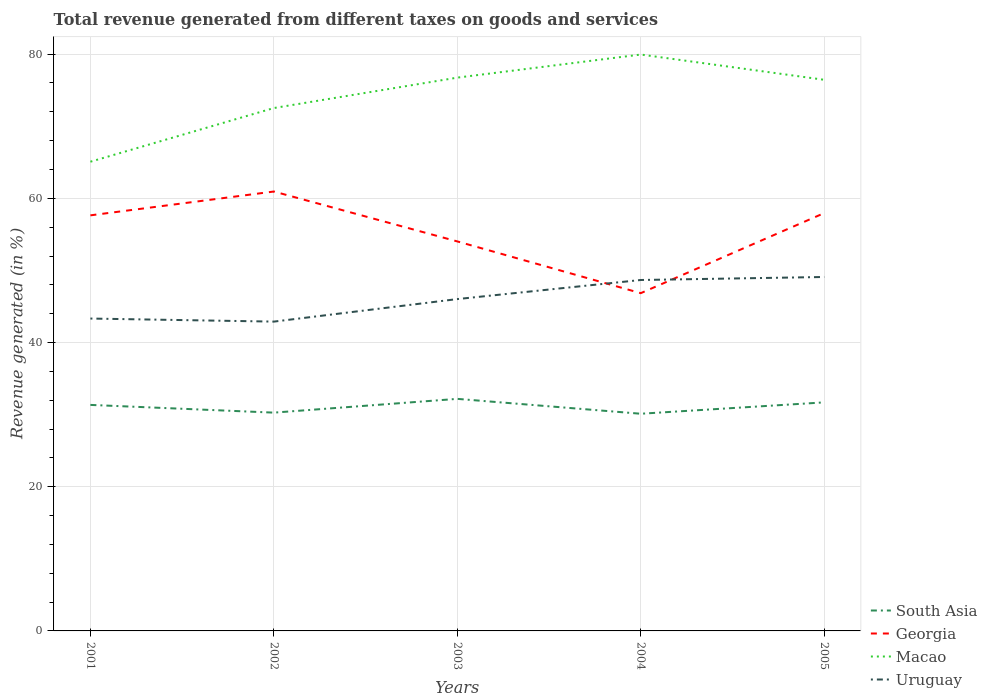How many different coloured lines are there?
Provide a succinct answer. 4. Does the line corresponding to Georgia intersect with the line corresponding to Macao?
Offer a terse response. No. Across all years, what is the maximum total revenue generated in Macao?
Offer a terse response. 65.08. In which year was the total revenue generated in Georgia maximum?
Make the answer very short. 2004. What is the total total revenue generated in South Asia in the graph?
Ensure brevity in your answer.  1.23. What is the difference between the highest and the second highest total revenue generated in Georgia?
Your response must be concise. 14.1. Does the graph contain grids?
Offer a terse response. Yes. How are the legend labels stacked?
Offer a terse response. Vertical. What is the title of the graph?
Your answer should be compact. Total revenue generated from different taxes on goods and services. What is the label or title of the Y-axis?
Offer a very short reply. Revenue generated (in %). What is the Revenue generated (in %) in South Asia in 2001?
Ensure brevity in your answer.  31.35. What is the Revenue generated (in %) of Georgia in 2001?
Provide a short and direct response. 57.64. What is the Revenue generated (in %) of Macao in 2001?
Make the answer very short. 65.08. What is the Revenue generated (in %) of Uruguay in 2001?
Your answer should be very brief. 43.33. What is the Revenue generated (in %) in South Asia in 2002?
Ensure brevity in your answer.  30.28. What is the Revenue generated (in %) of Georgia in 2002?
Provide a succinct answer. 60.94. What is the Revenue generated (in %) in Macao in 2002?
Your answer should be compact. 72.52. What is the Revenue generated (in %) of Uruguay in 2002?
Give a very brief answer. 42.9. What is the Revenue generated (in %) in South Asia in 2003?
Your response must be concise. 32.19. What is the Revenue generated (in %) in Georgia in 2003?
Make the answer very short. 54.02. What is the Revenue generated (in %) in Macao in 2003?
Offer a very short reply. 76.74. What is the Revenue generated (in %) of Uruguay in 2003?
Make the answer very short. 46.03. What is the Revenue generated (in %) of South Asia in 2004?
Offer a terse response. 30.12. What is the Revenue generated (in %) in Georgia in 2004?
Keep it short and to the point. 46.85. What is the Revenue generated (in %) of Macao in 2004?
Provide a short and direct response. 79.94. What is the Revenue generated (in %) in Uruguay in 2004?
Make the answer very short. 48.67. What is the Revenue generated (in %) in South Asia in 2005?
Keep it short and to the point. 31.7. What is the Revenue generated (in %) of Georgia in 2005?
Ensure brevity in your answer.  57.95. What is the Revenue generated (in %) in Macao in 2005?
Ensure brevity in your answer.  76.44. What is the Revenue generated (in %) in Uruguay in 2005?
Make the answer very short. 49.09. Across all years, what is the maximum Revenue generated (in %) in South Asia?
Provide a short and direct response. 32.19. Across all years, what is the maximum Revenue generated (in %) of Georgia?
Offer a very short reply. 60.94. Across all years, what is the maximum Revenue generated (in %) in Macao?
Offer a very short reply. 79.94. Across all years, what is the maximum Revenue generated (in %) of Uruguay?
Ensure brevity in your answer.  49.09. Across all years, what is the minimum Revenue generated (in %) in South Asia?
Keep it short and to the point. 30.12. Across all years, what is the minimum Revenue generated (in %) in Georgia?
Keep it short and to the point. 46.85. Across all years, what is the minimum Revenue generated (in %) of Macao?
Give a very brief answer. 65.08. Across all years, what is the minimum Revenue generated (in %) of Uruguay?
Your answer should be very brief. 42.9. What is the total Revenue generated (in %) of South Asia in the graph?
Make the answer very short. 155.63. What is the total Revenue generated (in %) of Georgia in the graph?
Your response must be concise. 277.41. What is the total Revenue generated (in %) of Macao in the graph?
Keep it short and to the point. 370.73. What is the total Revenue generated (in %) in Uruguay in the graph?
Your response must be concise. 230.01. What is the difference between the Revenue generated (in %) of South Asia in 2001 and that in 2002?
Offer a very short reply. 1.07. What is the difference between the Revenue generated (in %) of Georgia in 2001 and that in 2002?
Keep it short and to the point. -3.31. What is the difference between the Revenue generated (in %) of Macao in 2001 and that in 2002?
Your answer should be very brief. -7.45. What is the difference between the Revenue generated (in %) in Uruguay in 2001 and that in 2002?
Keep it short and to the point. 0.43. What is the difference between the Revenue generated (in %) of South Asia in 2001 and that in 2003?
Provide a short and direct response. -0.84. What is the difference between the Revenue generated (in %) of Georgia in 2001 and that in 2003?
Give a very brief answer. 3.62. What is the difference between the Revenue generated (in %) in Macao in 2001 and that in 2003?
Give a very brief answer. -11.66. What is the difference between the Revenue generated (in %) of Uruguay in 2001 and that in 2003?
Make the answer very short. -2.7. What is the difference between the Revenue generated (in %) of South Asia in 2001 and that in 2004?
Ensure brevity in your answer.  1.23. What is the difference between the Revenue generated (in %) of Georgia in 2001 and that in 2004?
Offer a very short reply. 10.79. What is the difference between the Revenue generated (in %) in Macao in 2001 and that in 2004?
Offer a terse response. -14.87. What is the difference between the Revenue generated (in %) in Uruguay in 2001 and that in 2004?
Make the answer very short. -5.35. What is the difference between the Revenue generated (in %) in South Asia in 2001 and that in 2005?
Offer a terse response. -0.35. What is the difference between the Revenue generated (in %) in Georgia in 2001 and that in 2005?
Provide a short and direct response. -0.31. What is the difference between the Revenue generated (in %) in Macao in 2001 and that in 2005?
Your answer should be compact. -11.36. What is the difference between the Revenue generated (in %) in Uruguay in 2001 and that in 2005?
Your answer should be compact. -5.76. What is the difference between the Revenue generated (in %) in South Asia in 2002 and that in 2003?
Provide a short and direct response. -1.91. What is the difference between the Revenue generated (in %) in Georgia in 2002 and that in 2003?
Provide a short and direct response. 6.92. What is the difference between the Revenue generated (in %) of Macao in 2002 and that in 2003?
Offer a terse response. -4.22. What is the difference between the Revenue generated (in %) in Uruguay in 2002 and that in 2003?
Provide a short and direct response. -3.13. What is the difference between the Revenue generated (in %) of South Asia in 2002 and that in 2004?
Provide a short and direct response. 0.15. What is the difference between the Revenue generated (in %) of Georgia in 2002 and that in 2004?
Your response must be concise. 14.1. What is the difference between the Revenue generated (in %) of Macao in 2002 and that in 2004?
Make the answer very short. -7.42. What is the difference between the Revenue generated (in %) in Uruguay in 2002 and that in 2004?
Ensure brevity in your answer.  -5.77. What is the difference between the Revenue generated (in %) of South Asia in 2002 and that in 2005?
Your response must be concise. -1.42. What is the difference between the Revenue generated (in %) in Georgia in 2002 and that in 2005?
Provide a short and direct response. 2.99. What is the difference between the Revenue generated (in %) of Macao in 2002 and that in 2005?
Keep it short and to the point. -3.92. What is the difference between the Revenue generated (in %) in Uruguay in 2002 and that in 2005?
Provide a succinct answer. -6.19. What is the difference between the Revenue generated (in %) of South Asia in 2003 and that in 2004?
Offer a very short reply. 2.06. What is the difference between the Revenue generated (in %) in Georgia in 2003 and that in 2004?
Your response must be concise. 7.18. What is the difference between the Revenue generated (in %) of Macao in 2003 and that in 2004?
Your answer should be very brief. -3.2. What is the difference between the Revenue generated (in %) of Uruguay in 2003 and that in 2004?
Provide a succinct answer. -2.65. What is the difference between the Revenue generated (in %) in South Asia in 2003 and that in 2005?
Give a very brief answer. 0.49. What is the difference between the Revenue generated (in %) in Georgia in 2003 and that in 2005?
Keep it short and to the point. -3.93. What is the difference between the Revenue generated (in %) of Macao in 2003 and that in 2005?
Provide a succinct answer. 0.3. What is the difference between the Revenue generated (in %) in Uruguay in 2003 and that in 2005?
Offer a terse response. -3.06. What is the difference between the Revenue generated (in %) in South Asia in 2004 and that in 2005?
Make the answer very short. -1.58. What is the difference between the Revenue generated (in %) in Georgia in 2004 and that in 2005?
Ensure brevity in your answer.  -11.11. What is the difference between the Revenue generated (in %) of Macao in 2004 and that in 2005?
Provide a succinct answer. 3.5. What is the difference between the Revenue generated (in %) in Uruguay in 2004 and that in 2005?
Give a very brief answer. -0.42. What is the difference between the Revenue generated (in %) of South Asia in 2001 and the Revenue generated (in %) of Georgia in 2002?
Give a very brief answer. -29.6. What is the difference between the Revenue generated (in %) in South Asia in 2001 and the Revenue generated (in %) in Macao in 2002?
Provide a short and direct response. -41.17. What is the difference between the Revenue generated (in %) of South Asia in 2001 and the Revenue generated (in %) of Uruguay in 2002?
Offer a very short reply. -11.55. What is the difference between the Revenue generated (in %) of Georgia in 2001 and the Revenue generated (in %) of Macao in 2002?
Provide a short and direct response. -14.88. What is the difference between the Revenue generated (in %) of Georgia in 2001 and the Revenue generated (in %) of Uruguay in 2002?
Provide a succinct answer. 14.74. What is the difference between the Revenue generated (in %) of Macao in 2001 and the Revenue generated (in %) of Uruguay in 2002?
Give a very brief answer. 22.18. What is the difference between the Revenue generated (in %) in South Asia in 2001 and the Revenue generated (in %) in Georgia in 2003?
Make the answer very short. -22.67. What is the difference between the Revenue generated (in %) in South Asia in 2001 and the Revenue generated (in %) in Macao in 2003?
Offer a terse response. -45.39. What is the difference between the Revenue generated (in %) of South Asia in 2001 and the Revenue generated (in %) of Uruguay in 2003?
Keep it short and to the point. -14.68. What is the difference between the Revenue generated (in %) in Georgia in 2001 and the Revenue generated (in %) in Macao in 2003?
Provide a succinct answer. -19.1. What is the difference between the Revenue generated (in %) in Georgia in 2001 and the Revenue generated (in %) in Uruguay in 2003?
Offer a very short reply. 11.61. What is the difference between the Revenue generated (in %) in Macao in 2001 and the Revenue generated (in %) in Uruguay in 2003?
Offer a terse response. 19.05. What is the difference between the Revenue generated (in %) of South Asia in 2001 and the Revenue generated (in %) of Georgia in 2004?
Offer a very short reply. -15.5. What is the difference between the Revenue generated (in %) of South Asia in 2001 and the Revenue generated (in %) of Macao in 2004?
Ensure brevity in your answer.  -48.59. What is the difference between the Revenue generated (in %) in South Asia in 2001 and the Revenue generated (in %) in Uruguay in 2004?
Ensure brevity in your answer.  -17.32. What is the difference between the Revenue generated (in %) in Georgia in 2001 and the Revenue generated (in %) in Macao in 2004?
Ensure brevity in your answer.  -22.3. What is the difference between the Revenue generated (in %) in Georgia in 2001 and the Revenue generated (in %) in Uruguay in 2004?
Ensure brevity in your answer.  8.97. What is the difference between the Revenue generated (in %) of Macao in 2001 and the Revenue generated (in %) of Uruguay in 2004?
Your answer should be compact. 16.41. What is the difference between the Revenue generated (in %) in South Asia in 2001 and the Revenue generated (in %) in Georgia in 2005?
Give a very brief answer. -26.6. What is the difference between the Revenue generated (in %) of South Asia in 2001 and the Revenue generated (in %) of Macao in 2005?
Your answer should be compact. -45.09. What is the difference between the Revenue generated (in %) of South Asia in 2001 and the Revenue generated (in %) of Uruguay in 2005?
Provide a succinct answer. -17.74. What is the difference between the Revenue generated (in %) in Georgia in 2001 and the Revenue generated (in %) in Macao in 2005?
Offer a very short reply. -18.8. What is the difference between the Revenue generated (in %) in Georgia in 2001 and the Revenue generated (in %) in Uruguay in 2005?
Provide a succinct answer. 8.55. What is the difference between the Revenue generated (in %) of Macao in 2001 and the Revenue generated (in %) of Uruguay in 2005?
Your answer should be compact. 15.99. What is the difference between the Revenue generated (in %) of South Asia in 2002 and the Revenue generated (in %) of Georgia in 2003?
Offer a terse response. -23.75. What is the difference between the Revenue generated (in %) in South Asia in 2002 and the Revenue generated (in %) in Macao in 2003?
Provide a short and direct response. -46.46. What is the difference between the Revenue generated (in %) of South Asia in 2002 and the Revenue generated (in %) of Uruguay in 2003?
Provide a short and direct response. -15.75. What is the difference between the Revenue generated (in %) of Georgia in 2002 and the Revenue generated (in %) of Macao in 2003?
Provide a short and direct response. -15.8. What is the difference between the Revenue generated (in %) in Georgia in 2002 and the Revenue generated (in %) in Uruguay in 2003?
Keep it short and to the point. 14.92. What is the difference between the Revenue generated (in %) in Macao in 2002 and the Revenue generated (in %) in Uruguay in 2003?
Your response must be concise. 26.5. What is the difference between the Revenue generated (in %) of South Asia in 2002 and the Revenue generated (in %) of Georgia in 2004?
Ensure brevity in your answer.  -16.57. What is the difference between the Revenue generated (in %) in South Asia in 2002 and the Revenue generated (in %) in Macao in 2004?
Provide a succinct answer. -49.67. What is the difference between the Revenue generated (in %) of South Asia in 2002 and the Revenue generated (in %) of Uruguay in 2004?
Give a very brief answer. -18.4. What is the difference between the Revenue generated (in %) in Georgia in 2002 and the Revenue generated (in %) in Macao in 2004?
Offer a very short reply. -19. What is the difference between the Revenue generated (in %) in Georgia in 2002 and the Revenue generated (in %) in Uruguay in 2004?
Provide a succinct answer. 12.27. What is the difference between the Revenue generated (in %) of Macao in 2002 and the Revenue generated (in %) of Uruguay in 2004?
Make the answer very short. 23.85. What is the difference between the Revenue generated (in %) in South Asia in 2002 and the Revenue generated (in %) in Georgia in 2005?
Your response must be concise. -27.68. What is the difference between the Revenue generated (in %) in South Asia in 2002 and the Revenue generated (in %) in Macao in 2005?
Offer a terse response. -46.17. What is the difference between the Revenue generated (in %) in South Asia in 2002 and the Revenue generated (in %) in Uruguay in 2005?
Your answer should be compact. -18.81. What is the difference between the Revenue generated (in %) of Georgia in 2002 and the Revenue generated (in %) of Macao in 2005?
Your response must be concise. -15.5. What is the difference between the Revenue generated (in %) in Georgia in 2002 and the Revenue generated (in %) in Uruguay in 2005?
Your answer should be very brief. 11.85. What is the difference between the Revenue generated (in %) of Macao in 2002 and the Revenue generated (in %) of Uruguay in 2005?
Keep it short and to the point. 23.43. What is the difference between the Revenue generated (in %) in South Asia in 2003 and the Revenue generated (in %) in Georgia in 2004?
Provide a succinct answer. -14.66. What is the difference between the Revenue generated (in %) of South Asia in 2003 and the Revenue generated (in %) of Macao in 2004?
Give a very brief answer. -47.76. What is the difference between the Revenue generated (in %) of South Asia in 2003 and the Revenue generated (in %) of Uruguay in 2004?
Provide a short and direct response. -16.49. What is the difference between the Revenue generated (in %) of Georgia in 2003 and the Revenue generated (in %) of Macao in 2004?
Offer a very short reply. -25.92. What is the difference between the Revenue generated (in %) of Georgia in 2003 and the Revenue generated (in %) of Uruguay in 2004?
Provide a short and direct response. 5.35. What is the difference between the Revenue generated (in %) of Macao in 2003 and the Revenue generated (in %) of Uruguay in 2004?
Your response must be concise. 28.07. What is the difference between the Revenue generated (in %) in South Asia in 2003 and the Revenue generated (in %) in Georgia in 2005?
Offer a very short reply. -25.77. What is the difference between the Revenue generated (in %) of South Asia in 2003 and the Revenue generated (in %) of Macao in 2005?
Offer a terse response. -44.26. What is the difference between the Revenue generated (in %) of South Asia in 2003 and the Revenue generated (in %) of Uruguay in 2005?
Keep it short and to the point. -16.9. What is the difference between the Revenue generated (in %) of Georgia in 2003 and the Revenue generated (in %) of Macao in 2005?
Give a very brief answer. -22.42. What is the difference between the Revenue generated (in %) of Georgia in 2003 and the Revenue generated (in %) of Uruguay in 2005?
Give a very brief answer. 4.93. What is the difference between the Revenue generated (in %) of Macao in 2003 and the Revenue generated (in %) of Uruguay in 2005?
Offer a terse response. 27.65. What is the difference between the Revenue generated (in %) of South Asia in 2004 and the Revenue generated (in %) of Georgia in 2005?
Ensure brevity in your answer.  -27.83. What is the difference between the Revenue generated (in %) in South Asia in 2004 and the Revenue generated (in %) in Macao in 2005?
Keep it short and to the point. -46.32. What is the difference between the Revenue generated (in %) of South Asia in 2004 and the Revenue generated (in %) of Uruguay in 2005?
Your answer should be very brief. -18.97. What is the difference between the Revenue generated (in %) in Georgia in 2004 and the Revenue generated (in %) in Macao in 2005?
Make the answer very short. -29.59. What is the difference between the Revenue generated (in %) in Georgia in 2004 and the Revenue generated (in %) in Uruguay in 2005?
Provide a succinct answer. -2.24. What is the difference between the Revenue generated (in %) in Macao in 2004 and the Revenue generated (in %) in Uruguay in 2005?
Give a very brief answer. 30.85. What is the average Revenue generated (in %) of South Asia per year?
Ensure brevity in your answer.  31.13. What is the average Revenue generated (in %) in Georgia per year?
Keep it short and to the point. 55.48. What is the average Revenue generated (in %) of Macao per year?
Offer a terse response. 74.15. What is the average Revenue generated (in %) of Uruguay per year?
Your answer should be very brief. 46. In the year 2001, what is the difference between the Revenue generated (in %) in South Asia and Revenue generated (in %) in Georgia?
Give a very brief answer. -26.29. In the year 2001, what is the difference between the Revenue generated (in %) in South Asia and Revenue generated (in %) in Macao?
Offer a very short reply. -33.73. In the year 2001, what is the difference between the Revenue generated (in %) of South Asia and Revenue generated (in %) of Uruguay?
Offer a terse response. -11.98. In the year 2001, what is the difference between the Revenue generated (in %) of Georgia and Revenue generated (in %) of Macao?
Your response must be concise. -7.44. In the year 2001, what is the difference between the Revenue generated (in %) of Georgia and Revenue generated (in %) of Uruguay?
Keep it short and to the point. 14.31. In the year 2001, what is the difference between the Revenue generated (in %) of Macao and Revenue generated (in %) of Uruguay?
Keep it short and to the point. 21.75. In the year 2002, what is the difference between the Revenue generated (in %) in South Asia and Revenue generated (in %) in Georgia?
Give a very brief answer. -30.67. In the year 2002, what is the difference between the Revenue generated (in %) in South Asia and Revenue generated (in %) in Macao?
Your response must be concise. -42.25. In the year 2002, what is the difference between the Revenue generated (in %) of South Asia and Revenue generated (in %) of Uruguay?
Your answer should be very brief. -12.62. In the year 2002, what is the difference between the Revenue generated (in %) in Georgia and Revenue generated (in %) in Macao?
Ensure brevity in your answer.  -11.58. In the year 2002, what is the difference between the Revenue generated (in %) in Georgia and Revenue generated (in %) in Uruguay?
Provide a short and direct response. 18.04. In the year 2002, what is the difference between the Revenue generated (in %) of Macao and Revenue generated (in %) of Uruguay?
Make the answer very short. 29.62. In the year 2003, what is the difference between the Revenue generated (in %) of South Asia and Revenue generated (in %) of Georgia?
Your answer should be compact. -21.84. In the year 2003, what is the difference between the Revenue generated (in %) in South Asia and Revenue generated (in %) in Macao?
Your answer should be very brief. -44.55. In the year 2003, what is the difference between the Revenue generated (in %) of South Asia and Revenue generated (in %) of Uruguay?
Provide a succinct answer. -13.84. In the year 2003, what is the difference between the Revenue generated (in %) in Georgia and Revenue generated (in %) in Macao?
Offer a terse response. -22.72. In the year 2003, what is the difference between the Revenue generated (in %) in Georgia and Revenue generated (in %) in Uruguay?
Give a very brief answer. 8. In the year 2003, what is the difference between the Revenue generated (in %) in Macao and Revenue generated (in %) in Uruguay?
Offer a terse response. 30.71. In the year 2004, what is the difference between the Revenue generated (in %) in South Asia and Revenue generated (in %) in Georgia?
Give a very brief answer. -16.72. In the year 2004, what is the difference between the Revenue generated (in %) of South Asia and Revenue generated (in %) of Macao?
Your answer should be compact. -49.82. In the year 2004, what is the difference between the Revenue generated (in %) of South Asia and Revenue generated (in %) of Uruguay?
Make the answer very short. -18.55. In the year 2004, what is the difference between the Revenue generated (in %) in Georgia and Revenue generated (in %) in Macao?
Offer a very short reply. -33.1. In the year 2004, what is the difference between the Revenue generated (in %) in Georgia and Revenue generated (in %) in Uruguay?
Provide a short and direct response. -1.83. In the year 2004, what is the difference between the Revenue generated (in %) in Macao and Revenue generated (in %) in Uruguay?
Give a very brief answer. 31.27. In the year 2005, what is the difference between the Revenue generated (in %) in South Asia and Revenue generated (in %) in Georgia?
Provide a succinct answer. -26.25. In the year 2005, what is the difference between the Revenue generated (in %) in South Asia and Revenue generated (in %) in Macao?
Make the answer very short. -44.74. In the year 2005, what is the difference between the Revenue generated (in %) in South Asia and Revenue generated (in %) in Uruguay?
Give a very brief answer. -17.39. In the year 2005, what is the difference between the Revenue generated (in %) of Georgia and Revenue generated (in %) of Macao?
Make the answer very short. -18.49. In the year 2005, what is the difference between the Revenue generated (in %) of Georgia and Revenue generated (in %) of Uruguay?
Provide a short and direct response. 8.86. In the year 2005, what is the difference between the Revenue generated (in %) of Macao and Revenue generated (in %) of Uruguay?
Your answer should be very brief. 27.35. What is the ratio of the Revenue generated (in %) in South Asia in 2001 to that in 2002?
Your response must be concise. 1.04. What is the ratio of the Revenue generated (in %) in Georgia in 2001 to that in 2002?
Your response must be concise. 0.95. What is the ratio of the Revenue generated (in %) in Macao in 2001 to that in 2002?
Ensure brevity in your answer.  0.9. What is the ratio of the Revenue generated (in %) in Uruguay in 2001 to that in 2002?
Your answer should be compact. 1.01. What is the ratio of the Revenue generated (in %) in South Asia in 2001 to that in 2003?
Provide a succinct answer. 0.97. What is the ratio of the Revenue generated (in %) in Georgia in 2001 to that in 2003?
Offer a terse response. 1.07. What is the ratio of the Revenue generated (in %) in Macao in 2001 to that in 2003?
Keep it short and to the point. 0.85. What is the ratio of the Revenue generated (in %) of Uruguay in 2001 to that in 2003?
Provide a short and direct response. 0.94. What is the ratio of the Revenue generated (in %) in South Asia in 2001 to that in 2004?
Your answer should be compact. 1.04. What is the ratio of the Revenue generated (in %) of Georgia in 2001 to that in 2004?
Your response must be concise. 1.23. What is the ratio of the Revenue generated (in %) of Macao in 2001 to that in 2004?
Provide a succinct answer. 0.81. What is the ratio of the Revenue generated (in %) of Uruguay in 2001 to that in 2004?
Offer a very short reply. 0.89. What is the ratio of the Revenue generated (in %) of South Asia in 2001 to that in 2005?
Ensure brevity in your answer.  0.99. What is the ratio of the Revenue generated (in %) of Georgia in 2001 to that in 2005?
Ensure brevity in your answer.  0.99. What is the ratio of the Revenue generated (in %) in Macao in 2001 to that in 2005?
Offer a terse response. 0.85. What is the ratio of the Revenue generated (in %) of Uruguay in 2001 to that in 2005?
Keep it short and to the point. 0.88. What is the ratio of the Revenue generated (in %) of South Asia in 2002 to that in 2003?
Provide a short and direct response. 0.94. What is the ratio of the Revenue generated (in %) of Georgia in 2002 to that in 2003?
Offer a very short reply. 1.13. What is the ratio of the Revenue generated (in %) in Macao in 2002 to that in 2003?
Make the answer very short. 0.94. What is the ratio of the Revenue generated (in %) in Uruguay in 2002 to that in 2003?
Keep it short and to the point. 0.93. What is the ratio of the Revenue generated (in %) in Georgia in 2002 to that in 2004?
Offer a very short reply. 1.3. What is the ratio of the Revenue generated (in %) of Macao in 2002 to that in 2004?
Ensure brevity in your answer.  0.91. What is the ratio of the Revenue generated (in %) of Uruguay in 2002 to that in 2004?
Offer a terse response. 0.88. What is the ratio of the Revenue generated (in %) of South Asia in 2002 to that in 2005?
Keep it short and to the point. 0.96. What is the ratio of the Revenue generated (in %) of Georgia in 2002 to that in 2005?
Offer a very short reply. 1.05. What is the ratio of the Revenue generated (in %) of Macao in 2002 to that in 2005?
Provide a short and direct response. 0.95. What is the ratio of the Revenue generated (in %) of Uruguay in 2002 to that in 2005?
Offer a very short reply. 0.87. What is the ratio of the Revenue generated (in %) in South Asia in 2003 to that in 2004?
Provide a succinct answer. 1.07. What is the ratio of the Revenue generated (in %) in Georgia in 2003 to that in 2004?
Ensure brevity in your answer.  1.15. What is the ratio of the Revenue generated (in %) in Macao in 2003 to that in 2004?
Keep it short and to the point. 0.96. What is the ratio of the Revenue generated (in %) in Uruguay in 2003 to that in 2004?
Give a very brief answer. 0.95. What is the ratio of the Revenue generated (in %) in South Asia in 2003 to that in 2005?
Ensure brevity in your answer.  1.02. What is the ratio of the Revenue generated (in %) in Georgia in 2003 to that in 2005?
Offer a very short reply. 0.93. What is the ratio of the Revenue generated (in %) in Macao in 2003 to that in 2005?
Your answer should be very brief. 1. What is the ratio of the Revenue generated (in %) of Uruguay in 2003 to that in 2005?
Offer a terse response. 0.94. What is the ratio of the Revenue generated (in %) of South Asia in 2004 to that in 2005?
Provide a succinct answer. 0.95. What is the ratio of the Revenue generated (in %) in Georgia in 2004 to that in 2005?
Provide a succinct answer. 0.81. What is the ratio of the Revenue generated (in %) of Macao in 2004 to that in 2005?
Your response must be concise. 1.05. What is the ratio of the Revenue generated (in %) of Uruguay in 2004 to that in 2005?
Provide a succinct answer. 0.99. What is the difference between the highest and the second highest Revenue generated (in %) in South Asia?
Your answer should be very brief. 0.49. What is the difference between the highest and the second highest Revenue generated (in %) in Georgia?
Make the answer very short. 2.99. What is the difference between the highest and the second highest Revenue generated (in %) of Macao?
Provide a short and direct response. 3.2. What is the difference between the highest and the second highest Revenue generated (in %) of Uruguay?
Offer a terse response. 0.42. What is the difference between the highest and the lowest Revenue generated (in %) of South Asia?
Provide a succinct answer. 2.06. What is the difference between the highest and the lowest Revenue generated (in %) in Georgia?
Your answer should be very brief. 14.1. What is the difference between the highest and the lowest Revenue generated (in %) of Macao?
Offer a very short reply. 14.87. What is the difference between the highest and the lowest Revenue generated (in %) of Uruguay?
Your answer should be very brief. 6.19. 